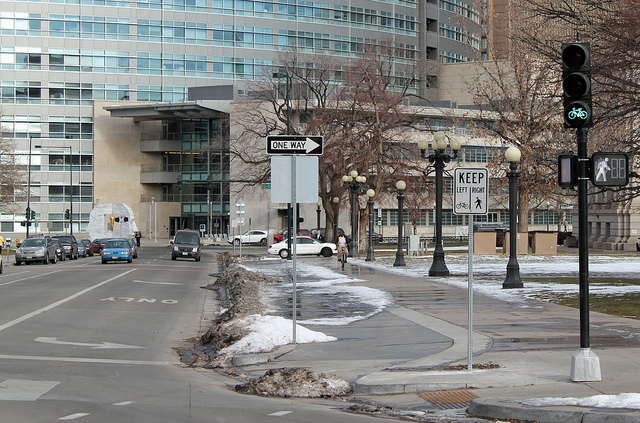Please transcribe the text information in this image. ONE WAY KEEP Left Right 88 ONLY 